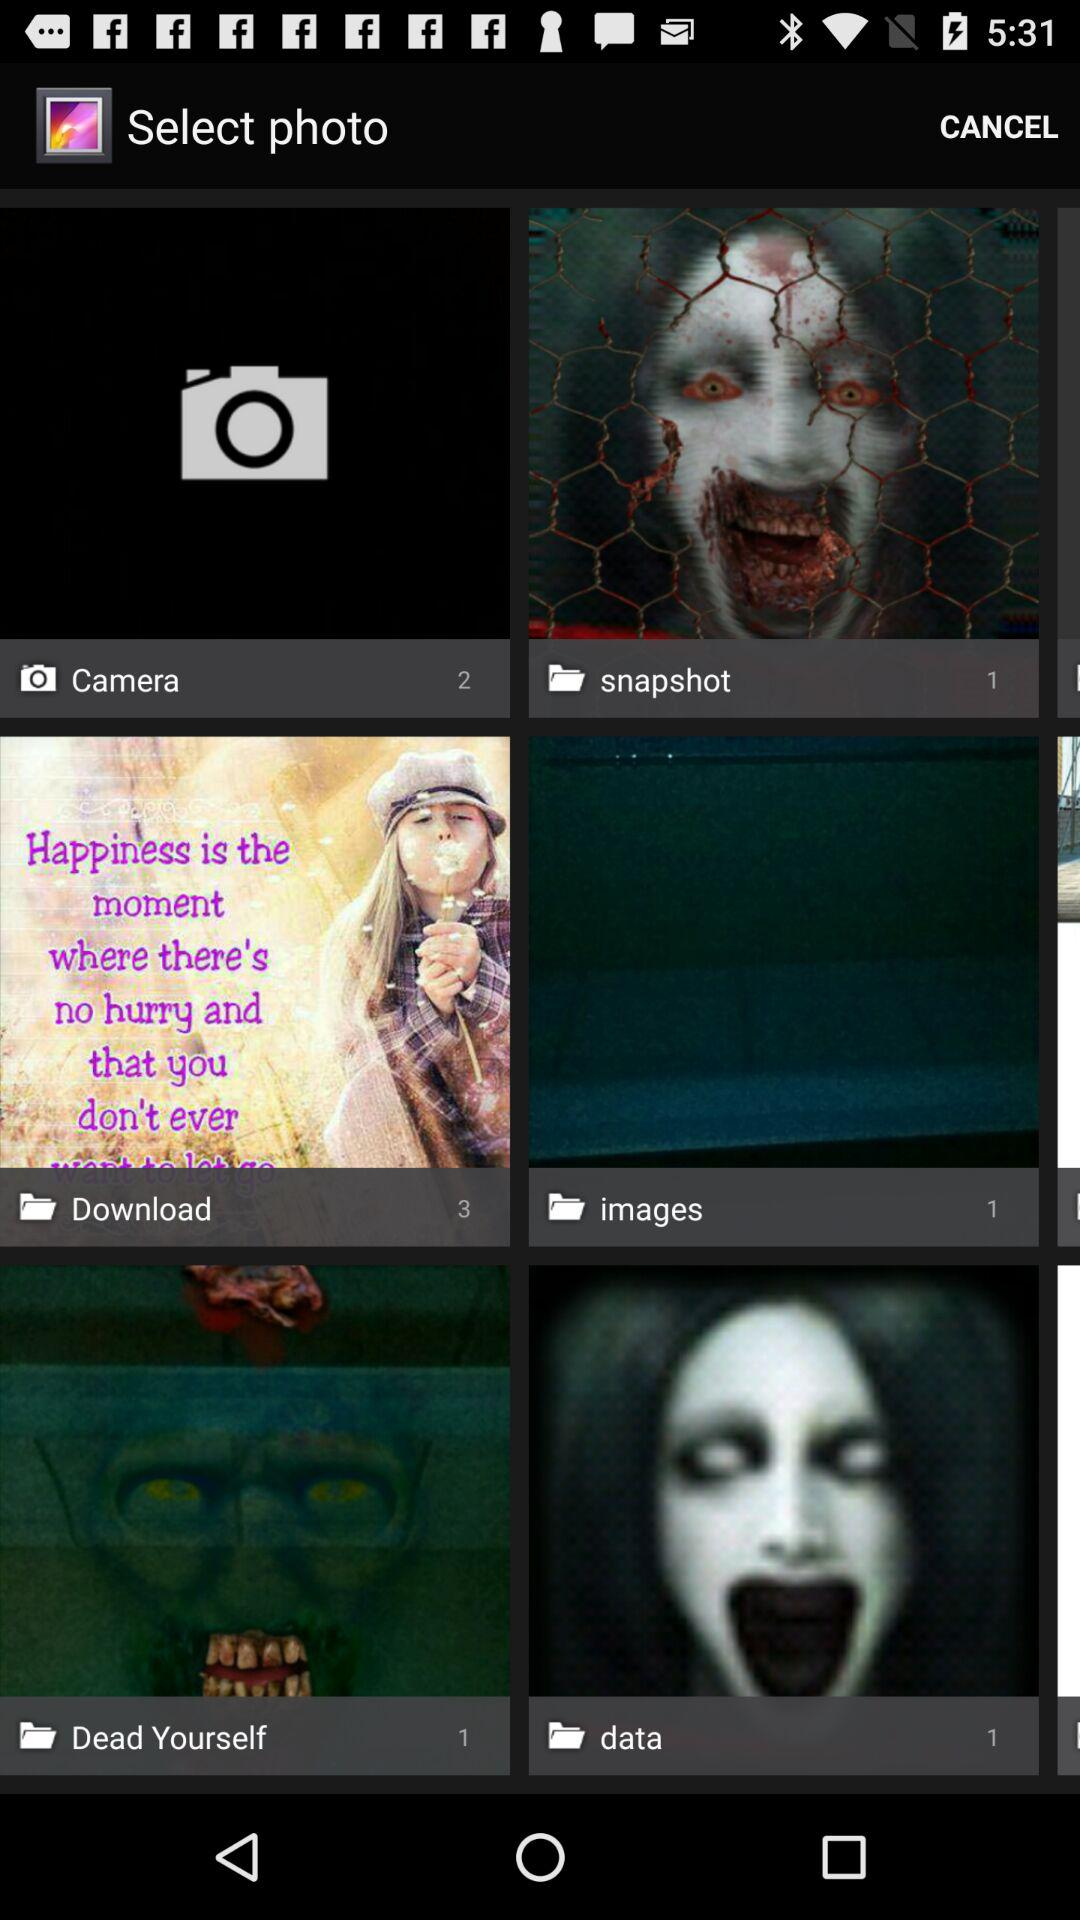What is the count of pictures in the "images" folder? The count of pictures in the "images" folder is 1. 